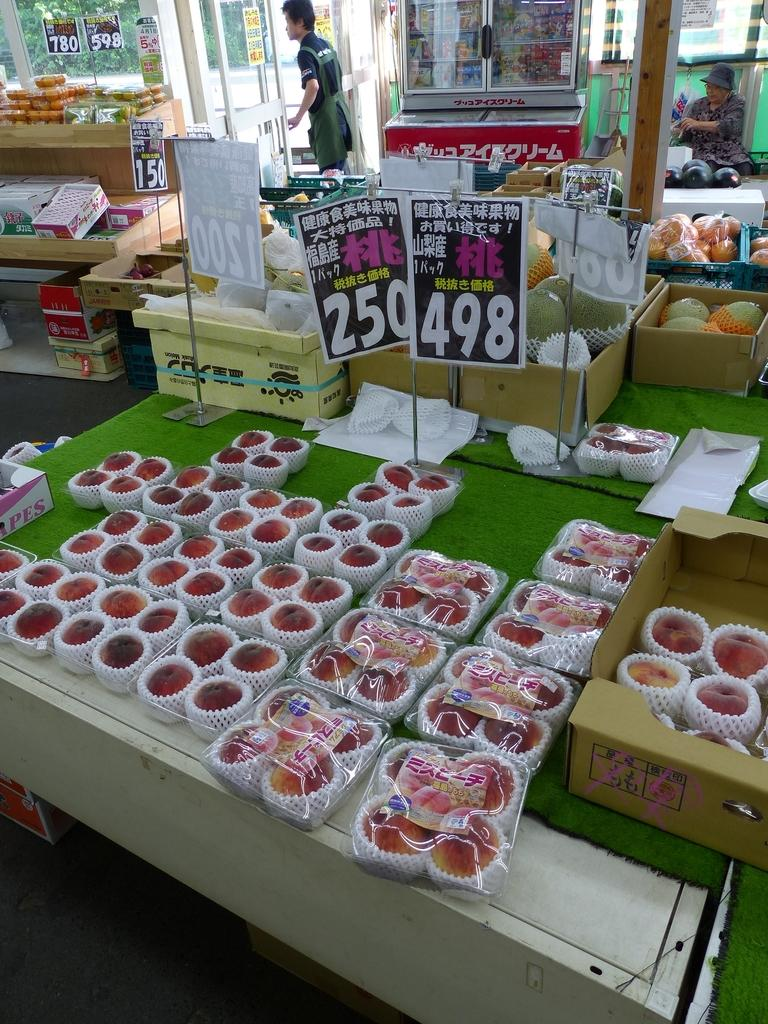Provide a one-sentence caption for the provided image. A sign with Chinese writing displaying 498 sitting on a table covered in green paper. 